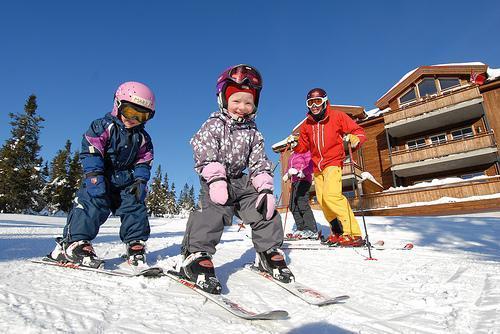How many people can you see?
Give a very brief answer. 4. How many kids are wearing pink helmet?
Give a very brief answer. 1. 